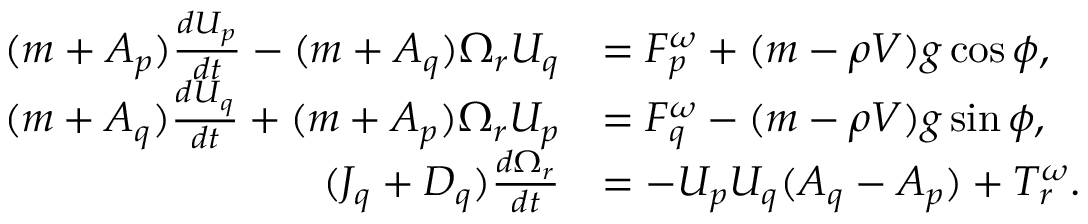<formula> <loc_0><loc_0><loc_500><loc_500>\begin{array} { r l } { ( m + A _ { p } ) \frac { d U _ { p } } { d t } - ( m + A _ { q } ) \Omega _ { r } U _ { q } } & { = F _ { p } ^ { \omega } + ( m - \rho V ) g \cos \phi , } \\ { ( m + A _ { q } ) \frac { d U _ { q } } { d t } + ( m + A _ { p } ) \Omega _ { r } U _ { p } } & { = F _ { q } ^ { \omega } - ( m - \rho V ) g \sin \phi , } \\ { ( J _ { q } + D _ { q } ) \frac { d \Omega _ { r } } { d t } } & { = - U _ { p } U _ { q } ( A _ { q } - A _ { p } ) + T _ { r } ^ { \omega } . } \end{array}</formula> 